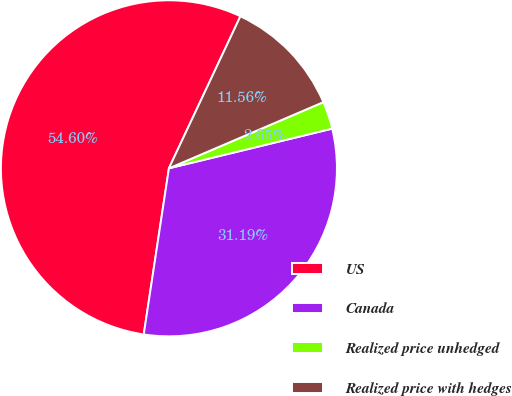Convert chart to OTSL. <chart><loc_0><loc_0><loc_500><loc_500><pie_chart><fcel>US<fcel>Canada<fcel>Realized price unhedged<fcel>Realized price with hedges<nl><fcel>54.6%<fcel>31.19%<fcel>2.65%<fcel>11.56%<nl></chart> 